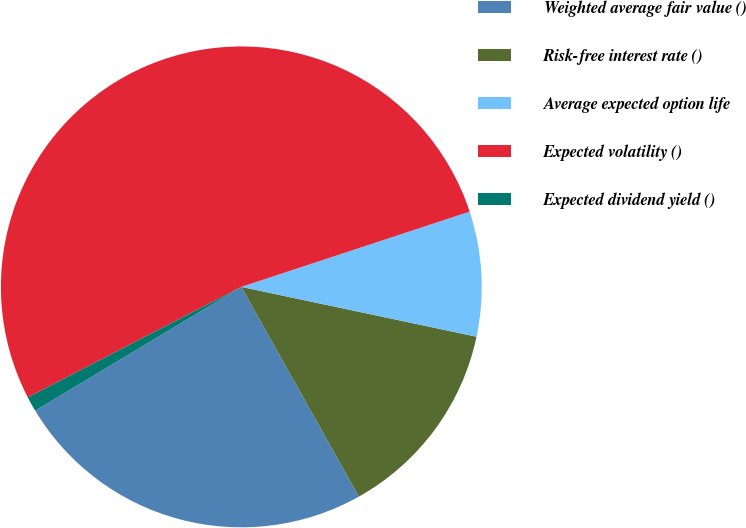<chart> <loc_0><loc_0><loc_500><loc_500><pie_chart><fcel>Weighted average fair value ()<fcel>Risk-free interest rate ()<fcel>Average expected option life<fcel>Expected volatility ()<fcel>Expected dividend yield ()<nl><fcel>24.53%<fcel>13.54%<fcel>8.39%<fcel>52.53%<fcel>1.0%<nl></chart> 